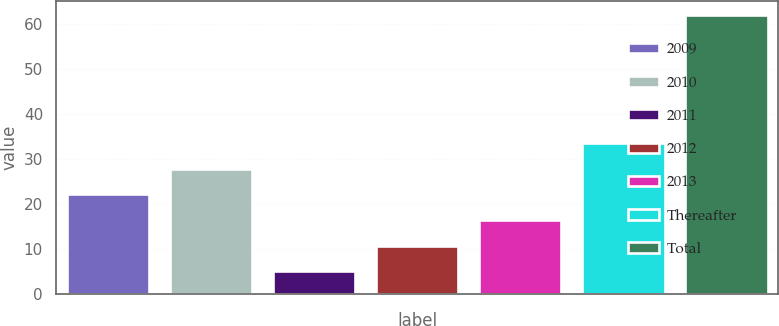Convert chart to OTSL. <chart><loc_0><loc_0><loc_500><loc_500><bar_chart><fcel>2009<fcel>2010<fcel>2011<fcel>2012<fcel>2013<fcel>Thereafter<fcel>Total<nl><fcel>22.1<fcel>27.8<fcel>5<fcel>10.7<fcel>16.4<fcel>33.5<fcel>62<nl></chart> 